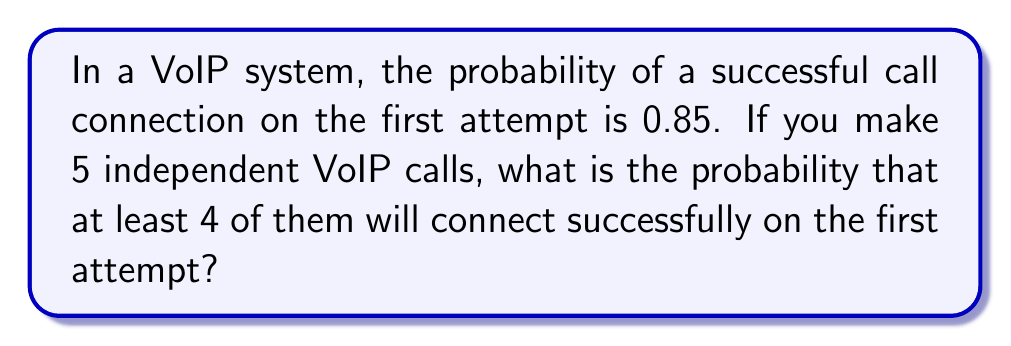Provide a solution to this math problem. Let's approach this step-by-step:

1) This is a binomial probability problem. We need to calculate the probability of 4 or 5 successful connections out of 5 attempts.

2) The probability of success (p) is 0.85, and the probability of failure (q) is 1 - 0.85 = 0.15.

3) We can use the binomial probability formula:

   $$P(X = k) = \binom{n}{k} p^k q^{n-k}$$

   where n is the number of trials, k is the number of successes, p is the probability of success, and q is the probability of failure.

4) We need to calculate P(X = 4) + P(X = 5):

   $$P(X \geq 4) = P(X = 4) + P(X = 5)$$

5) For 4 successes:
   $$P(X = 4) = \binom{5}{4} (0.85)^4 (0.15)^1 = 5 \times 0.85^4 \times 0.15 = 0.4376$$

6) For 5 successes:
   $$P(X = 5) = \binom{5}{5} (0.85)^5 (0.15)^0 = 1 \times 0.85^5 = 0.4437$$

7) Adding these probabilities:
   $$P(X \geq 4) = 0.4376 + 0.4437 = 0.8813$$

Therefore, the probability of at least 4 successful connections out of 5 attempts is approximately 0.8813 or 88.13%.
Answer: 0.8813 